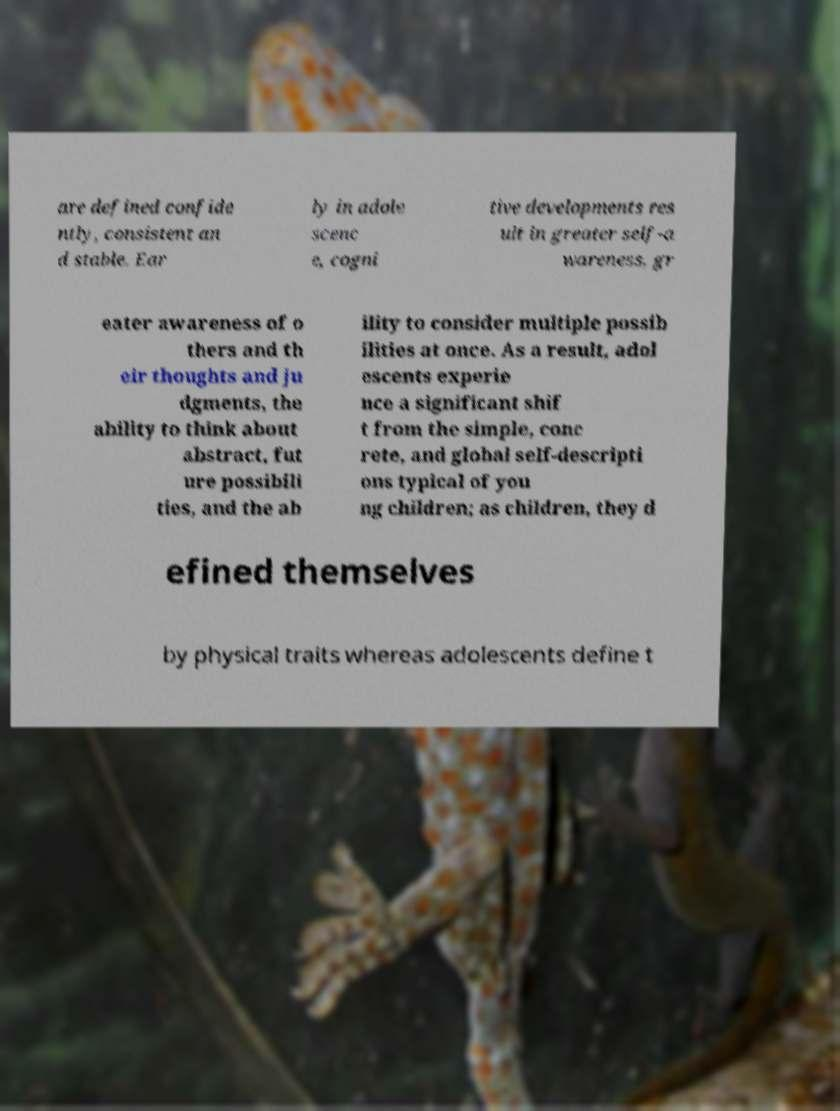Could you extract and type out the text from this image? are defined confide ntly, consistent an d stable. Ear ly in adole scenc e, cogni tive developments res ult in greater self-a wareness, gr eater awareness of o thers and th eir thoughts and ju dgments, the ability to think about abstract, fut ure possibili ties, and the ab ility to consider multiple possib ilities at once. As a result, adol escents experie nce a significant shif t from the simple, conc rete, and global self-descripti ons typical of you ng children; as children, they d efined themselves by physical traits whereas adolescents define t 